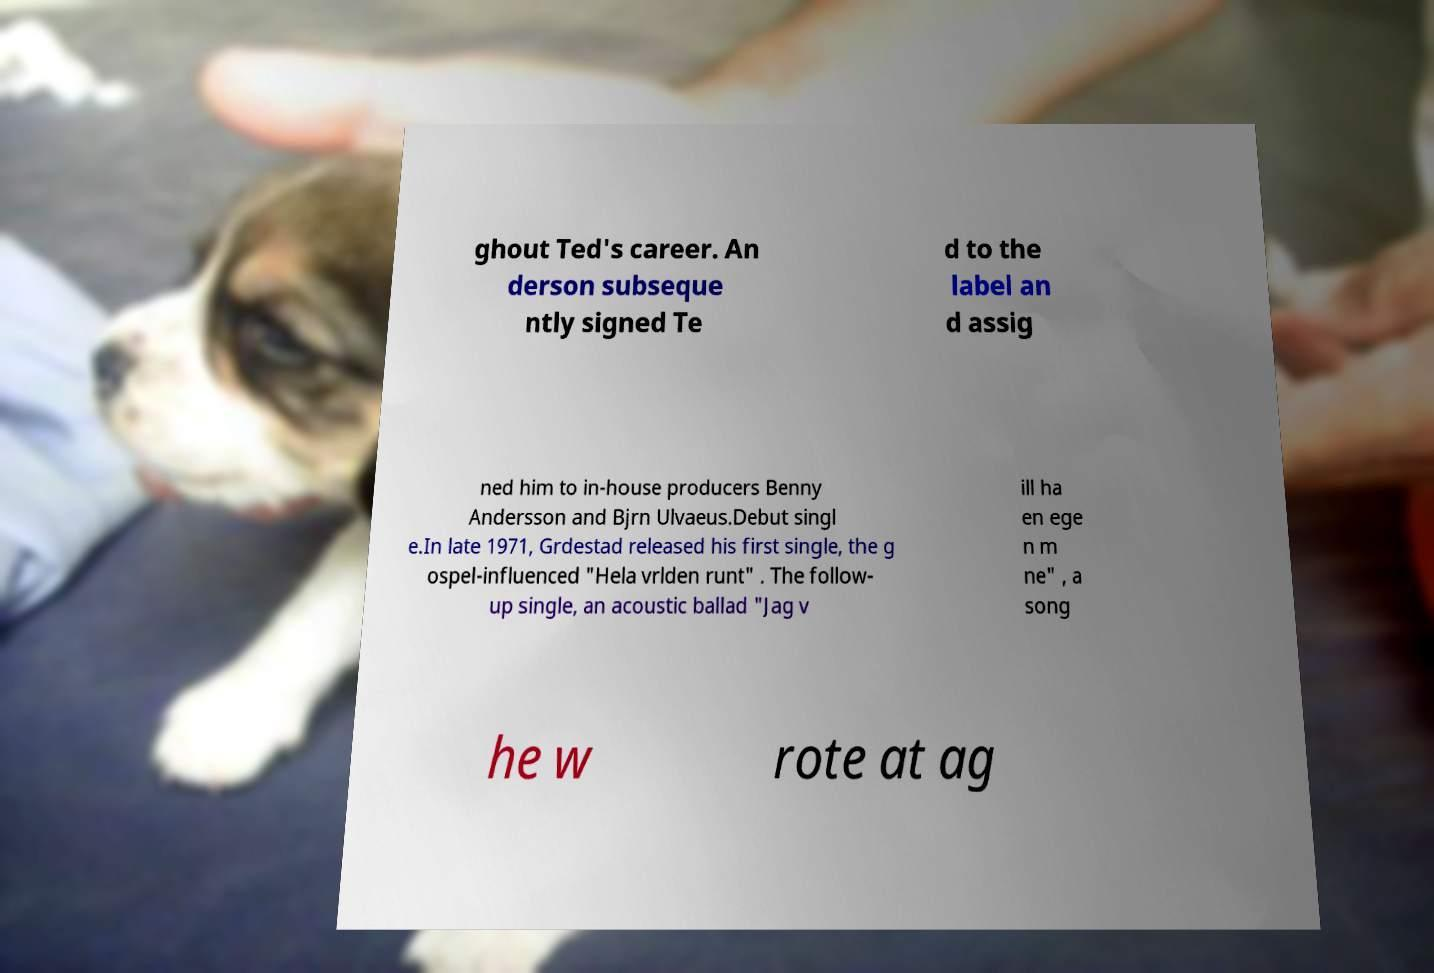Please identify and transcribe the text found in this image. ghout Ted's career. An derson subseque ntly signed Te d to the label an d assig ned him to in-house producers Benny Andersson and Bjrn Ulvaeus.Debut singl e.In late 1971, Grdestad released his first single, the g ospel-influenced "Hela vrlden runt" . The follow- up single, an acoustic ballad "Jag v ill ha en ege n m ne" , a song he w rote at ag 